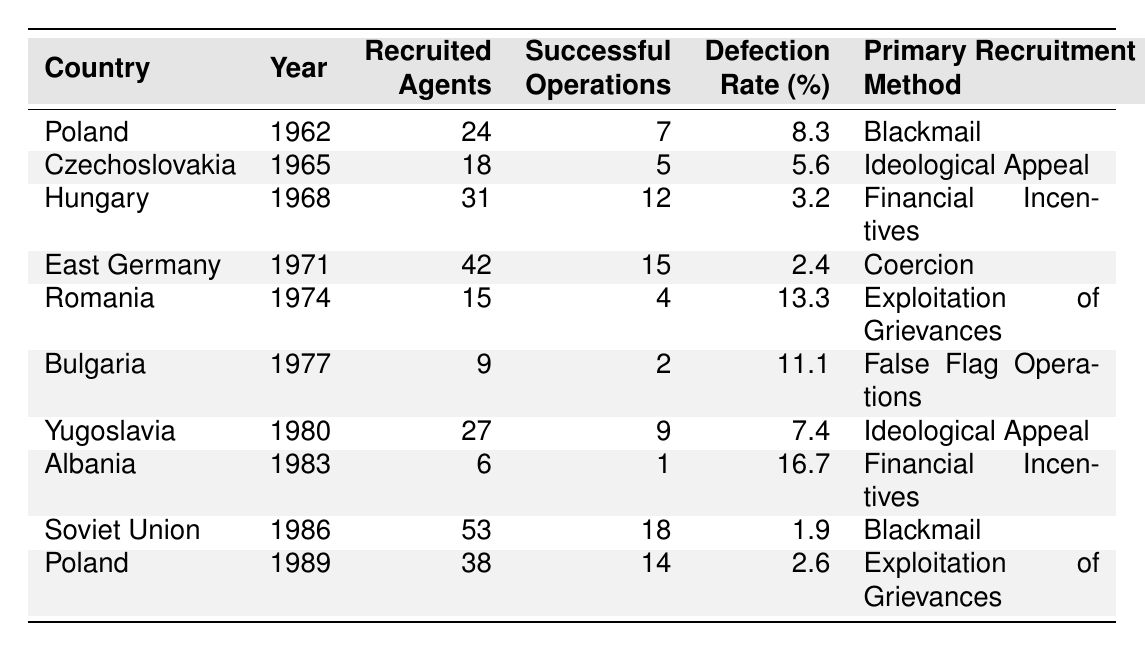What was the highest number of recruited agents in a single year? The highest number of recruited agents is found in the "Soviet Union" in 1986, with a total of 53 agents.
Answer: 53 Which country had the lowest defection rate and what was it? To find this, I compare the defection rates across all countries. The country with the lowest defection rate is the "Soviet Union" in 1986, with a rate of 1.9%.
Answer: 1.9% What method was primarily used in Hungary for recruitment? In the entry for Hungary from 1968, the primary recruitment method listed is "Financial Incentives."
Answer: Financial Incentives How many successful operations were conducted in East Germany compared to Poland in 1989? East Germany had 15 successful operations in 1971 while Poland had 14 in 1989. Comparing these values shows East Germany had more successful operations than Poland.
Answer: East Germany had more What is the average number of recruited agents in the table? I sum the total recruited agents: (24 + 18 + 31 + 42 + 15 + 9 + 27 + 6 + 53 + 38) = 263. There are 10 data points, so the average is 263/10 = 26.3.
Answer: 26.3 Was ideological appeal more successful than coercion in East Germany's recruitment operations? Ideological appeal in Czechoslovakia had 5 successful operations, while coercion in East Germany had 15 successful operations. Hence, coercion was more successful.
Answer: No Which country had the highest defection rate and what recruitment method was used? The highest defection rate is 16.7% for Albania in 1983, which used "Financial Incentives" as the recruitment method.
Answer: Albania: 16.7%, Financial Incentives How many successful operations were carried out, on average, per recruited agent across all countries? First, compute the total successful operations (7 + 5 + 12 + 15 + 4 + 2 + 9 + 1 + 18 + 14) = 83 and total recruited agents = 263. The average is 83/263 ≈ 0.316.
Answer: ≈ 0.316 What was the recruitment method used in Romania and what was its defection rate? The recruitment method used in Romania in 1974 was "Exploitation of Grievances," and the defection rate was 13.3%.
Answer: Exploitation of Grievances, 13.3% How does the defection rate in Bulgaria compare with that in Romania? Bulgaria had a defection rate of 11.1% while Romania had a rate of 13.3%. This indicates that Bulgaria's rate is lower than Romania's.
Answer: Bulgaria's rate is lower 